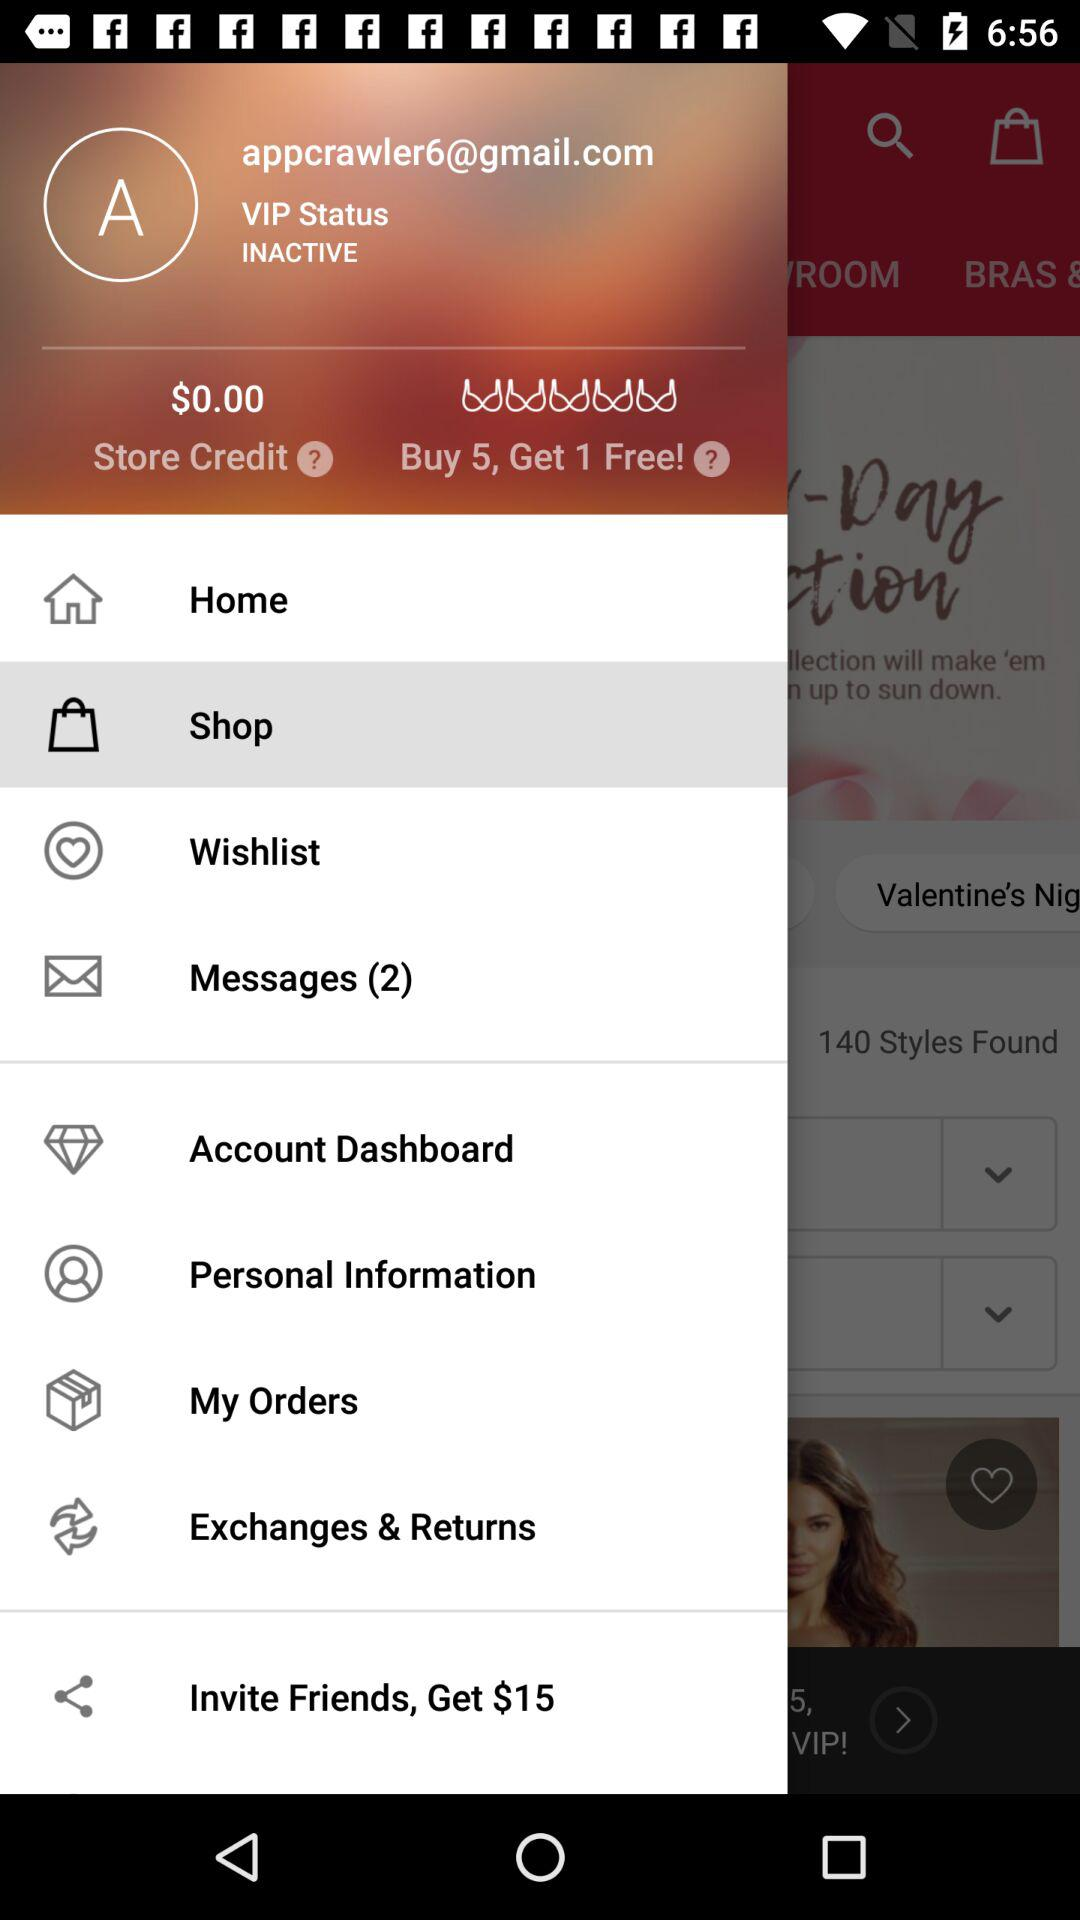How much is the store credit? The store credit is $0.00. 